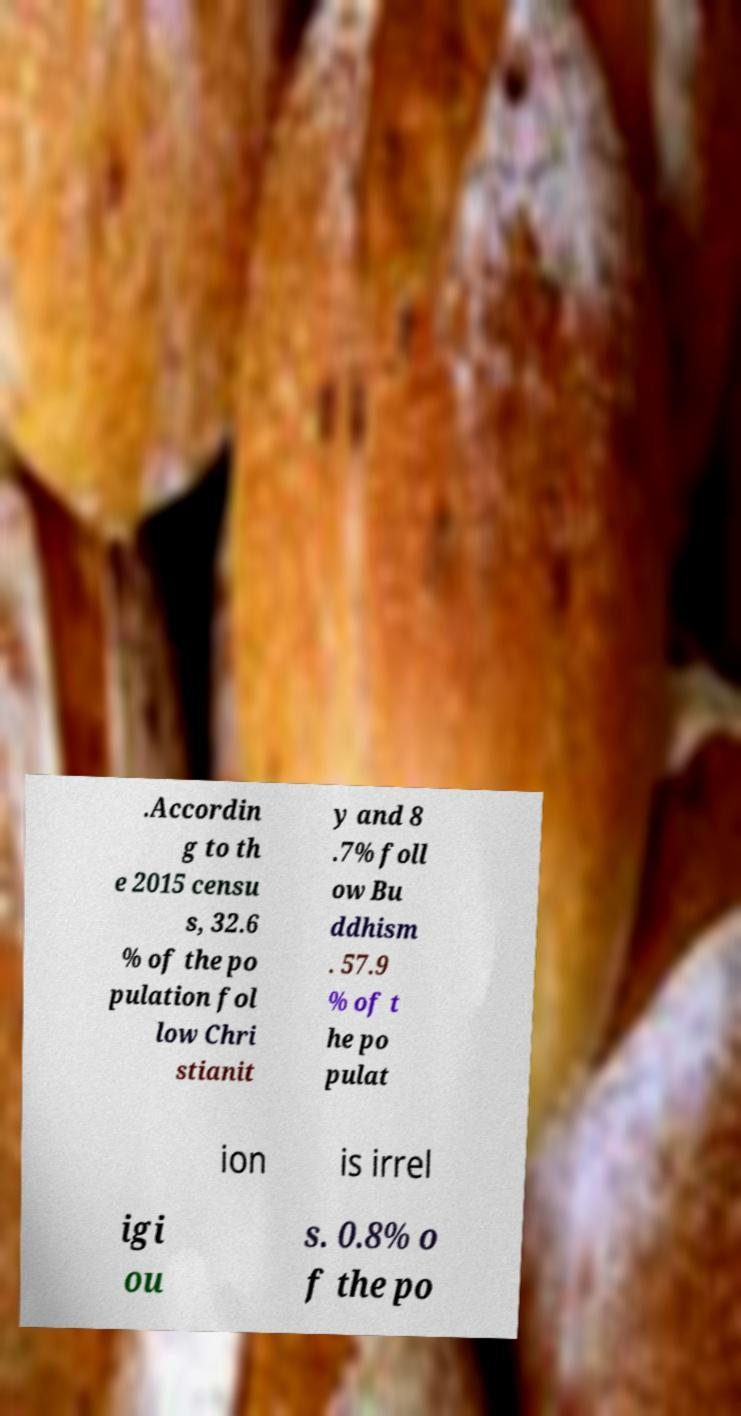Please read and relay the text visible in this image. What does it say? .Accordin g to th e 2015 censu s, 32.6 % of the po pulation fol low Chri stianit y and 8 .7% foll ow Bu ddhism . 57.9 % of t he po pulat ion is irrel igi ou s. 0.8% o f the po 